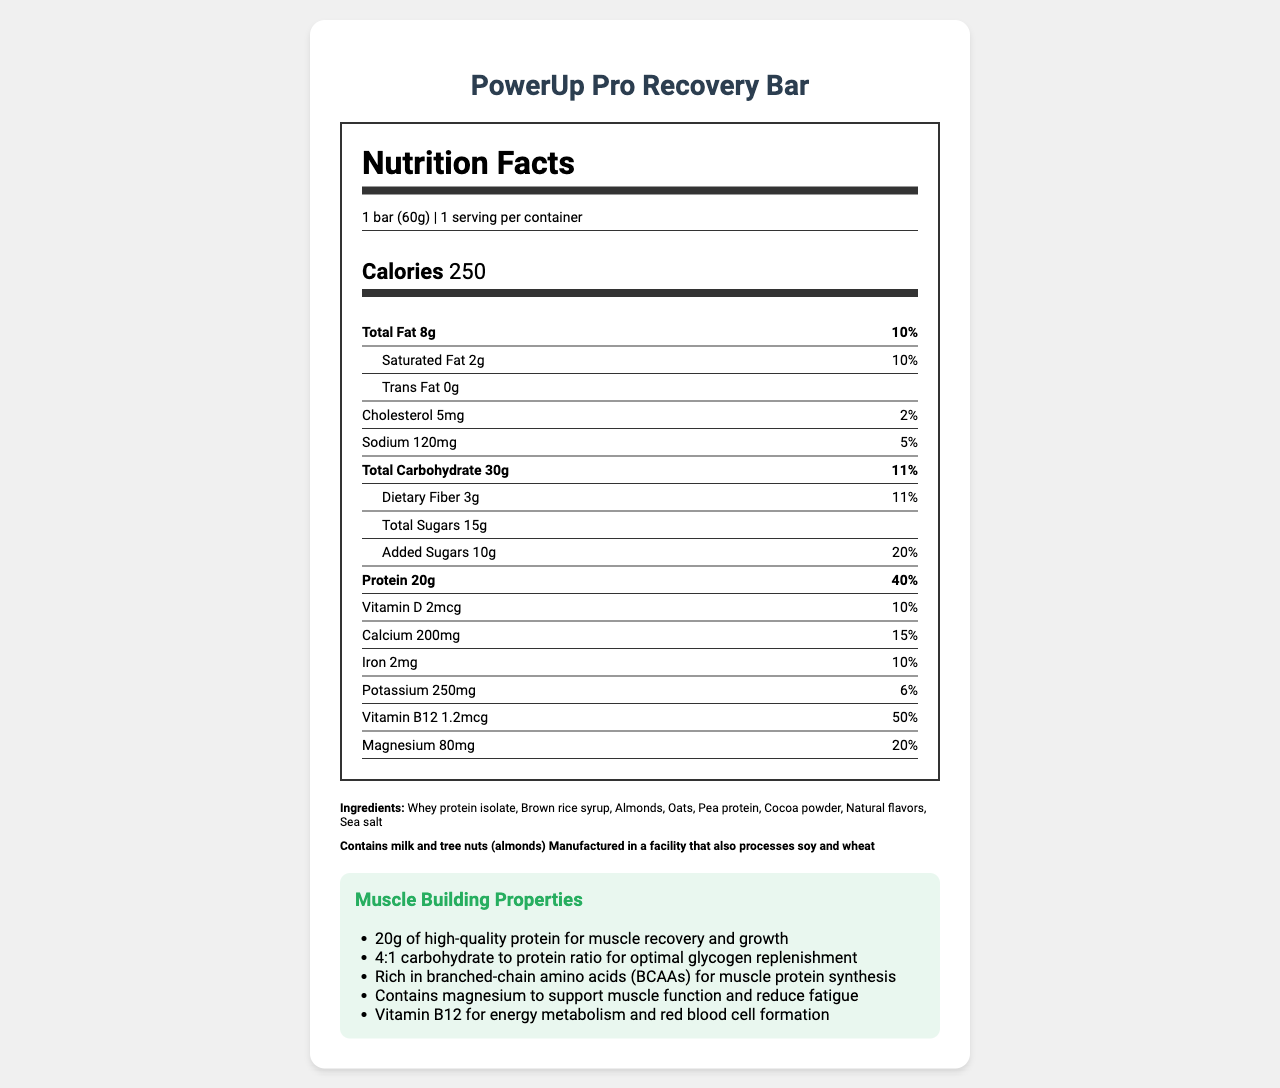what is the serving size of the PowerUp Pro Recovery Bar? The serving size is clearly mentioned in the document as "1 bar (60g)".
Answer: 1 bar (60g) How much protein is in one serving of the PowerUp Pro Recovery Bar? The protein content is listed in the nutrient section as "Protein 20g".
Answer: 20g What percentage of the daily value of Vitamin B12 does one PowerUp Pro Recovery Bar provide? The daily value for Vitamin B12 is shown as "50%" in the relevant section of the document.
Answer: 50% List the top three muscle-building properties of the PowerUp Pro Recovery Bar. The top three properties listed under "Muscle Building Properties" are "20g of high-quality protein for muscle recovery and growth," "4:1 carbohydrate to protein ratio for optimal glycogen replenishment," and "Rich in branched-chain amino acids (BCAAs) for muscle protein synthesis."
Answer: 20g of high-quality protein, 4:1 carbohydrate to protein ratio, Rich in branched-chain amino acids (BCAAs) How much calcium does one PowerUp Pro Recovery Bar contain? The document lists the calcium content as "200mg".
Answer: 200mg Identify one major allergen present in the PowerUp Pro Recovery Bar. The document mentions, "Contains milk and tree nuts (almonds)".
Answer: Tree nuts (almonds) What is the calorie content of the PowerUp Pro Recovery Bar? The calorie content is clearly mentioned as "Calories 250".
Answer: 250 calories Which ingredient is present in the largest quantity in the PowerUp Pro Recovery Bar? A. Brown rice syrup B. Whey protein isolate C. Almonds Ingredients are typically listed in order of quantity, and the first ingredient listed is "Whey protein isolate".
Answer: B. Whey protein isolate What is the daily value percentage of saturated fat in one serving of this bar? A. 5% B. 10% C. 15% The document states "Saturated Fat 2g" with a daily value percentage of "10%".
Answer: B. 10% Does the PowerUp Pro Recovery Bar contain any trans fat? The document clearly lists "Trans Fat 0g" indicating that the bar contains no trans fat.
Answer: No Summarize the main nutritional benefits of the PowerUp Pro Recovery Bar. The main nutritional benefits highlighted in the document include a high protein content, optimal carbohydrate-protein ratio, presence of BCAAs, and essential vitamins and minerals designed to support muscle recovery and overall performance.
Answer: The PowerUp Pro Recovery Bar is designed for post-workout recovery, providing 20g of high-quality protein, 4:1 carbohydrate to protein ratio, and is rich in BCAAs and other essential vitamins and minerals. It supports muscle recovery, energy replenishment, and overall athletic performance. How many total sugars are in one PowerUp Pro Recovery Bar? The document lists "Total Sugars 15g."
Answer: 15g Can you determine the shelf life of the PowerUp Pro Recovery Bar from this document? The document provides comprehensive nutritional information but does not mention the shelf life of the product.
Answer: Cannot be determined What is the role of magnesium in the PowerUp Pro Recovery Bar according to the muscle-building properties section? The muscle-building properties section mentions that magnesium "supports muscle function and reduces fatigue."
Answer: Magnesium supports muscle function and reduces fatigue. 